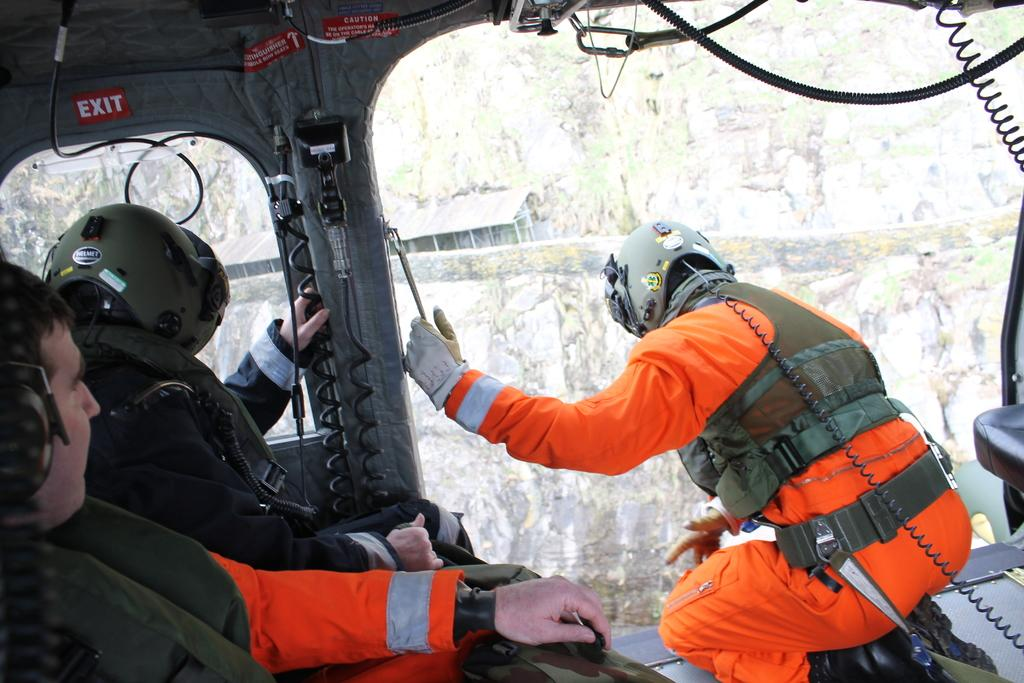Who is present in the image? There are people in the image. What are the people wearing? The people are wearing helmets. Where are the people sitting in the image? The people are sitting in a plane. What can be seen in the background of the image? There are hills visible in the background of the image. What time of day is it in the image, based on the position of the sun? There is no indication of the time of day or the position of the sun in the image. 